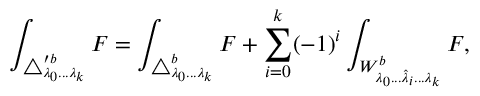<formula> <loc_0><loc_0><loc_500><loc_500>\int _ { \triangle _ { \lambda _ { 0 } \dots \lambda _ { k } } ^ { \prime b } } F = \int _ { \triangle _ { \lambda _ { 0 } \dots \lambda _ { k } } ^ { b } } F + \sum _ { i = 0 } ^ { k } ( - 1 ) ^ { i } \int _ { W _ { \lambda _ { 0 } \dots \hat { \lambda } _ { i } \dots \lambda _ { k } } ^ { b } } F ,</formula> 